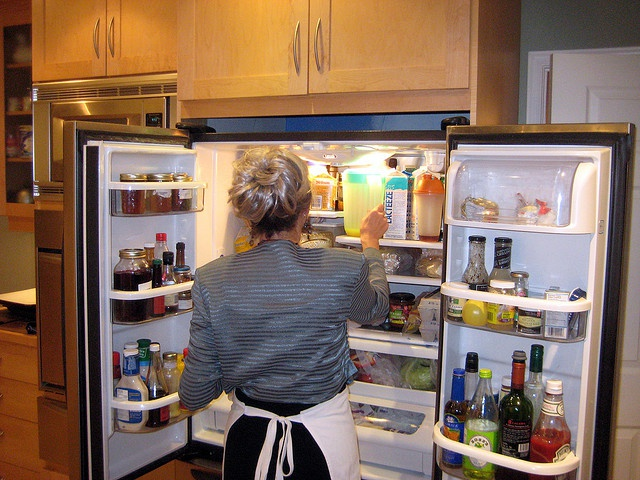Describe the objects in this image and their specific colors. I can see refrigerator in maroon, darkgray, black, lightgray, and gray tones, people in maroon, gray, and black tones, oven in maroon, olive, and black tones, microwave in maroon, olive, and black tones, and bottle in maroon, black, darkgray, and gray tones in this image. 